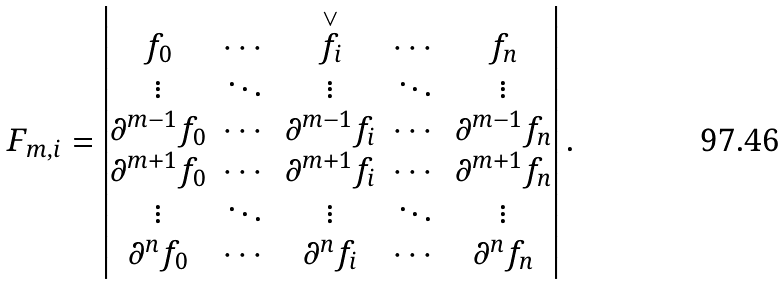<formula> <loc_0><loc_0><loc_500><loc_500>F _ { m , i } = \begin{vmatrix} f _ { 0 } & \cdots & { \stackrel { \vee } { f _ { i } } } & \cdots & f _ { n } \\ \vdots & \ddots & \vdots & \ddots & \vdots \\ \partial ^ { m - 1 } f _ { 0 } & \cdots & \partial ^ { m - 1 } f _ { i } & \cdots & \partial ^ { m - 1 } f _ { n } \\ \partial ^ { m + 1 } f _ { 0 } & \cdots & \partial ^ { m + 1 } f _ { i } & \cdots & \partial ^ { m + 1 } f _ { n } \\ \vdots & \ddots & \vdots & \ddots & \vdots \\ \partial ^ { n } f _ { 0 } & \cdots & \partial ^ { n } f _ { i } & \cdots & \partial ^ { n } f _ { n } \end{vmatrix} .</formula> 